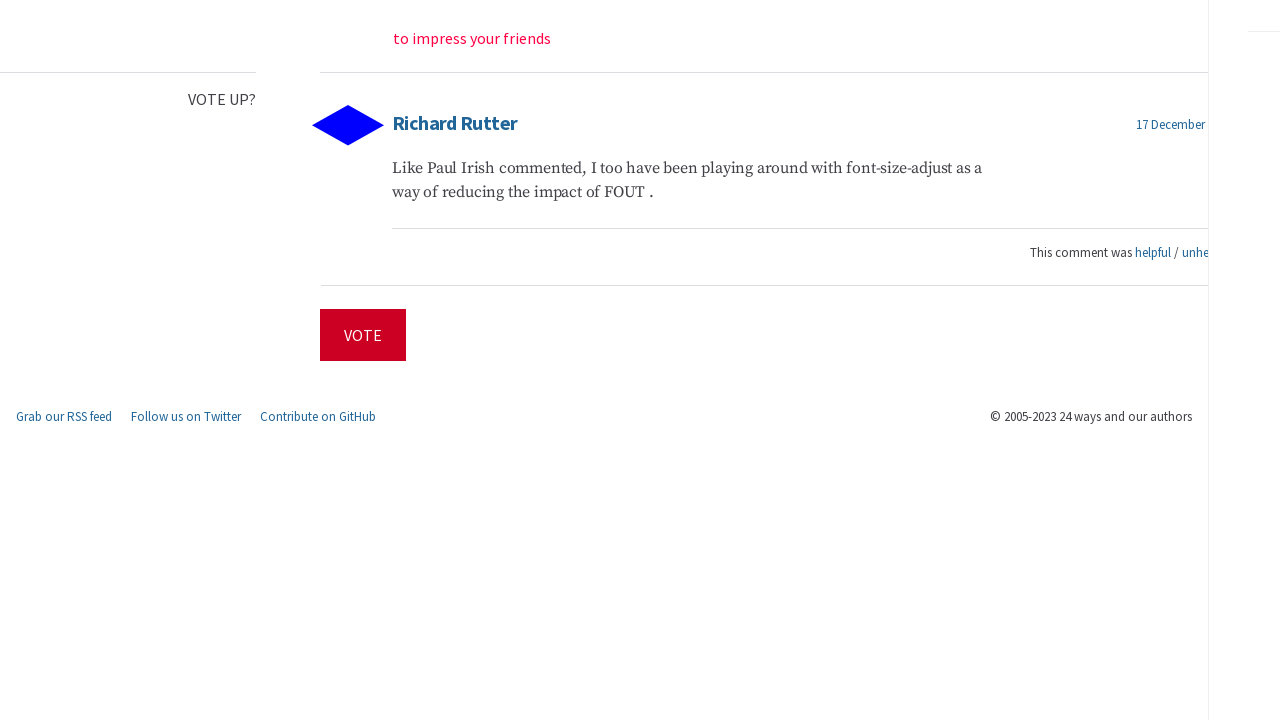Can you explain the purpose of the comment section in the website’s context? The comment section in the website serves as a platform for community engagement, allowing readers to share their opinions or insights related to the article. This interaction not only enriches the content but also fosters a sense of community among readers who can exchange thoughts and potentially influence content direction through voting mechanisms. How does the voting feature impact user engagement? The voting feature enhances user engagement by empowering readers to express their preferences directly, rewarding content they find helpful and demoting what they don’t. Such features can drive more active participation and keep users returning, contributing to a more dynamic and interactive community experience. 